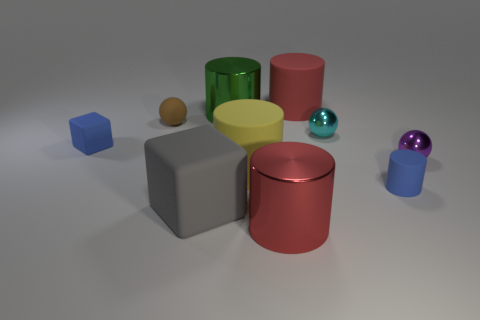Can you describe the colorful layout and what kind of mood or setting it might represent? The variety of colors and simple geometric shapes could represent a playful or artistic setting, perhaps reminiscent of a children’s play area or a modern art exhibit. The understated colors and soft lighting give the scene a calm, harmonious feeling, suggesting a tranquil and thought-provoking environment. 